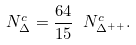<formula> <loc_0><loc_0><loc_500><loc_500>N _ { \Delta } ^ { c } = \frac { 6 4 } { 1 5 } \ N _ { \Delta ^ { + + } } ^ { c } .</formula> 